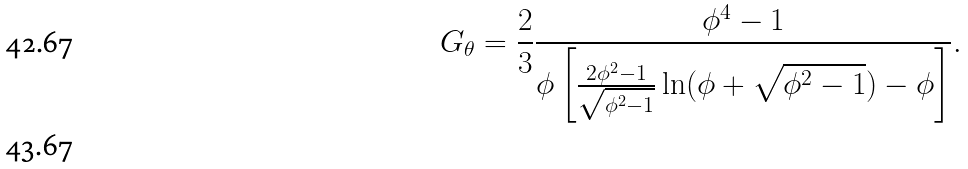<formula> <loc_0><loc_0><loc_500><loc_500>G _ { \theta } = \frac { 2 } { 3 } \frac { \phi ^ { 4 } - 1 } { \phi \left [ \frac { 2 \phi ^ { 2 } - 1 } { \sqrt { \phi ^ { 2 } - 1 } } \ln ( \phi + \sqrt { \phi ^ { 2 } - 1 } ) - \phi \right ] } . \\</formula> 